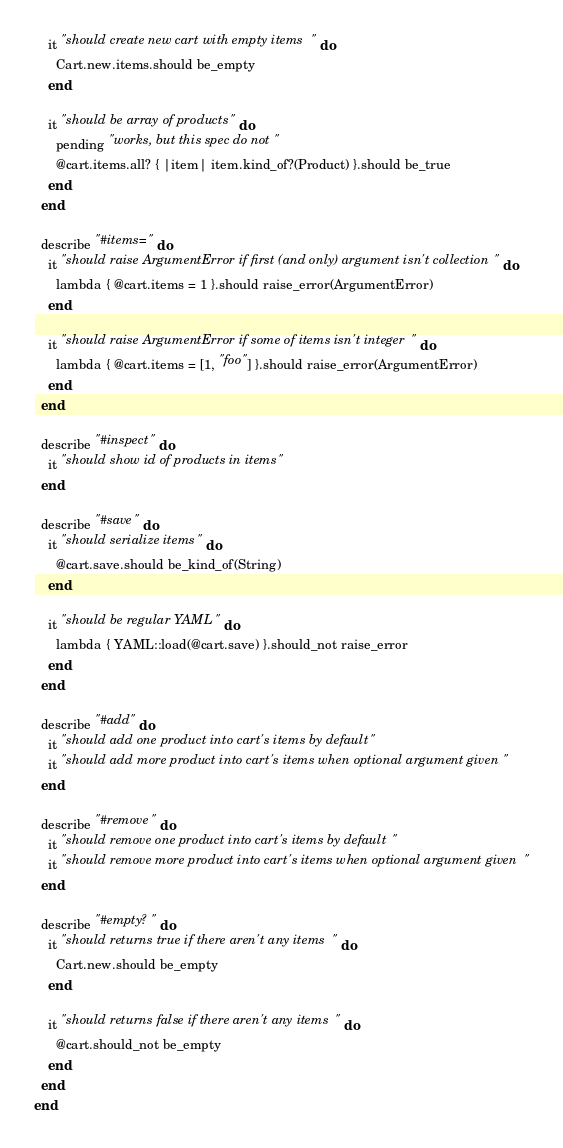Convert code to text. <code><loc_0><loc_0><loc_500><loc_500><_Ruby_>    it "should create new cart with empty items" do
      Cart.new.items.should be_empty
    end

    it "should be array of products" do
      pending "works, but this spec do not"
      @cart.items.all? { |item| item.kind_of?(Product) }.should be_true
    end
  end

  describe "#items=" do
    it "should raise ArgumentError if first (and only) argument isn't collection" do
      lambda { @cart.items = 1 }.should raise_error(ArgumentError)
    end

    it "should raise ArgumentError if some of items isn't integer" do
      lambda { @cart.items = [1, "foo"] }.should raise_error(ArgumentError)
    end
  end

  describe "#inspect" do
    it "should show id of products in items"
  end

  describe "#save" do
    it "should serialize items" do
      @cart.save.should be_kind_of(String)
    end

    it "should be regular YAML" do
      lambda { YAML::load(@cart.save) }.should_not raise_error
    end
  end

  describe "#add" do
    it "should add one product into cart's items by default"
    it "should add more product into cart's items when optional argument given"
  end

  describe "#remove" do
    it "should remove one product into cart's items by default"
    it "should remove more product into cart's items when optional argument given"
  end

  describe "#empty?" do
    it "should returns true if there aren't any items" do
      Cart.new.should be_empty
    end

    it "should returns false if there aren't any items" do
      @cart.should_not be_empty
    end
  end
end
</code> 